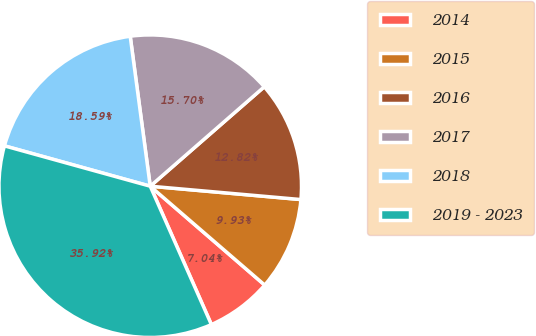Convert chart. <chart><loc_0><loc_0><loc_500><loc_500><pie_chart><fcel>2014<fcel>2015<fcel>2016<fcel>2017<fcel>2018<fcel>2019 - 2023<nl><fcel>7.04%<fcel>9.93%<fcel>12.82%<fcel>15.7%<fcel>18.59%<fcel>35.92%<nl></chart> 